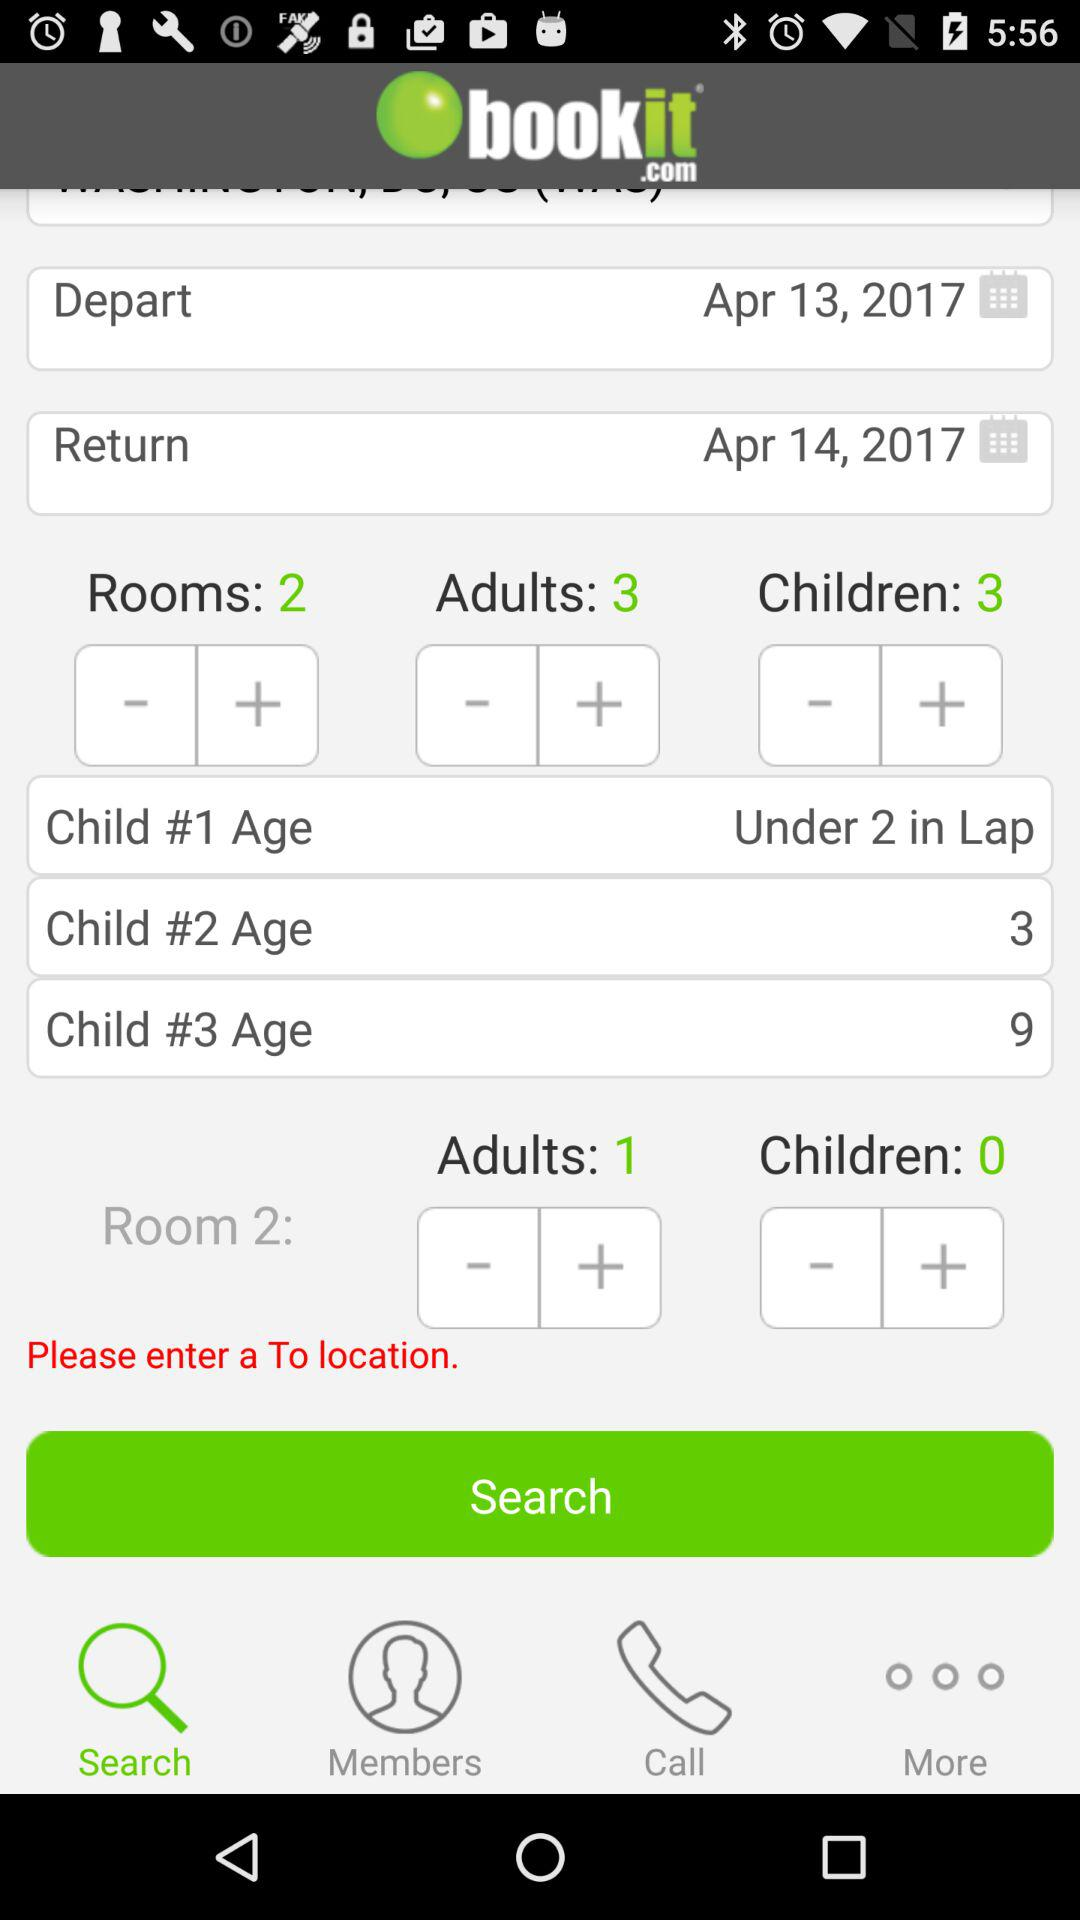What is the date of departure? The date of departure is April 13, 2017. 